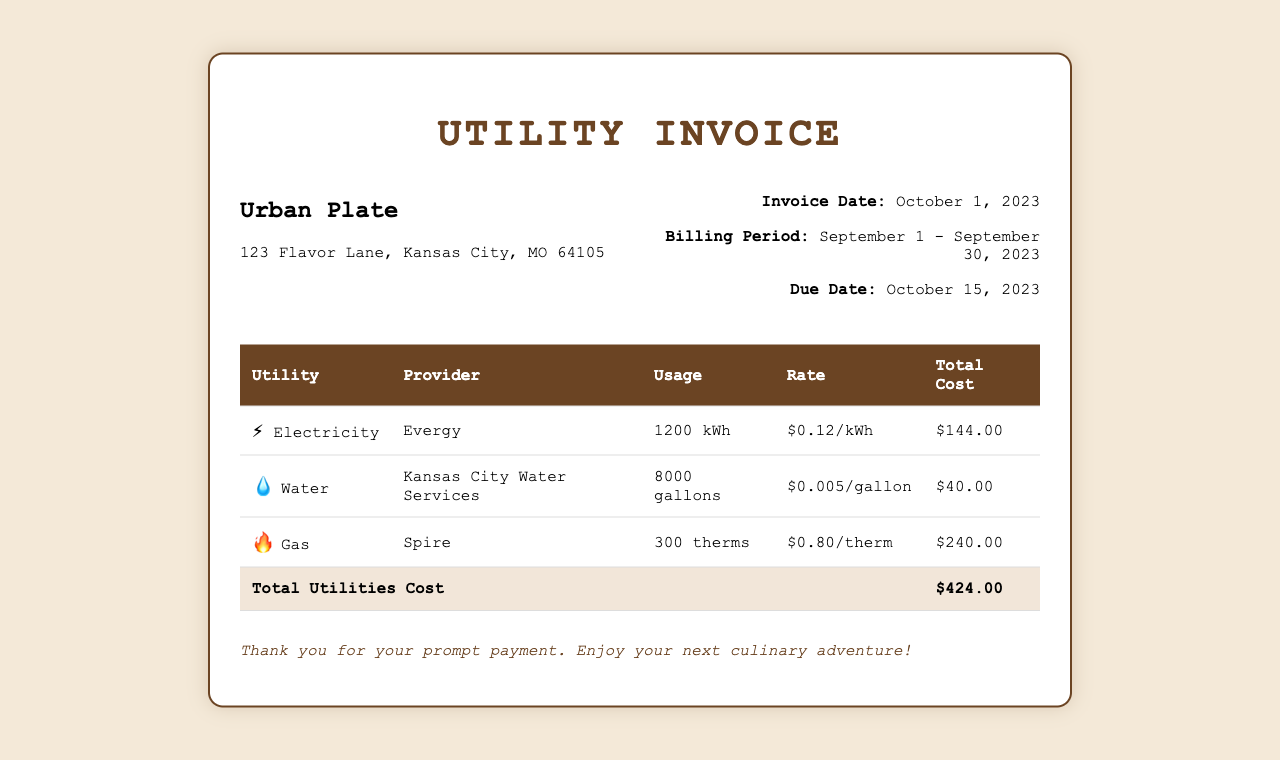What is the total cost for electricity? The total cost for electricity is found in the document under the Electricity section, which states $144.00.
Answer: $144.00 Who is the provider for water services? The provider for water services is mentioned as Kansas City Water Services in the document.
Answer: Kansas City Water Services What is the usage of gas in therms? The usage of gas is indicated as 300 therms in the Gas section of the invoice.
Answer: 300 therms What is the total utilities cost? The total utilities cost is calculated and presented at the bottom of the table as $424.00.
Answer: $424.00 When is the due date for payment? The due date for payment is stated in the invoice information section as October 15, 2023.
Answer: October 15, 2023 How much is the rate per gallon for water? The rate per gallon for water is given in the invoice as $0.005/gallon.
Answer: $0.005/gallon What is the billing period for this invoice? The billing period is specified in the invoice information as September 1 - September 30, 2023.
Answer: September 1 - September 30, 2023 Which utility has the highest total cost? By comparing the total costs listed, Gas has the highest total cost of $240.00.
Answer: Gas What is the usage for electricity? The usage for electricity is listed in the document as 1200 kWh.
Answer: 1200 kWh 